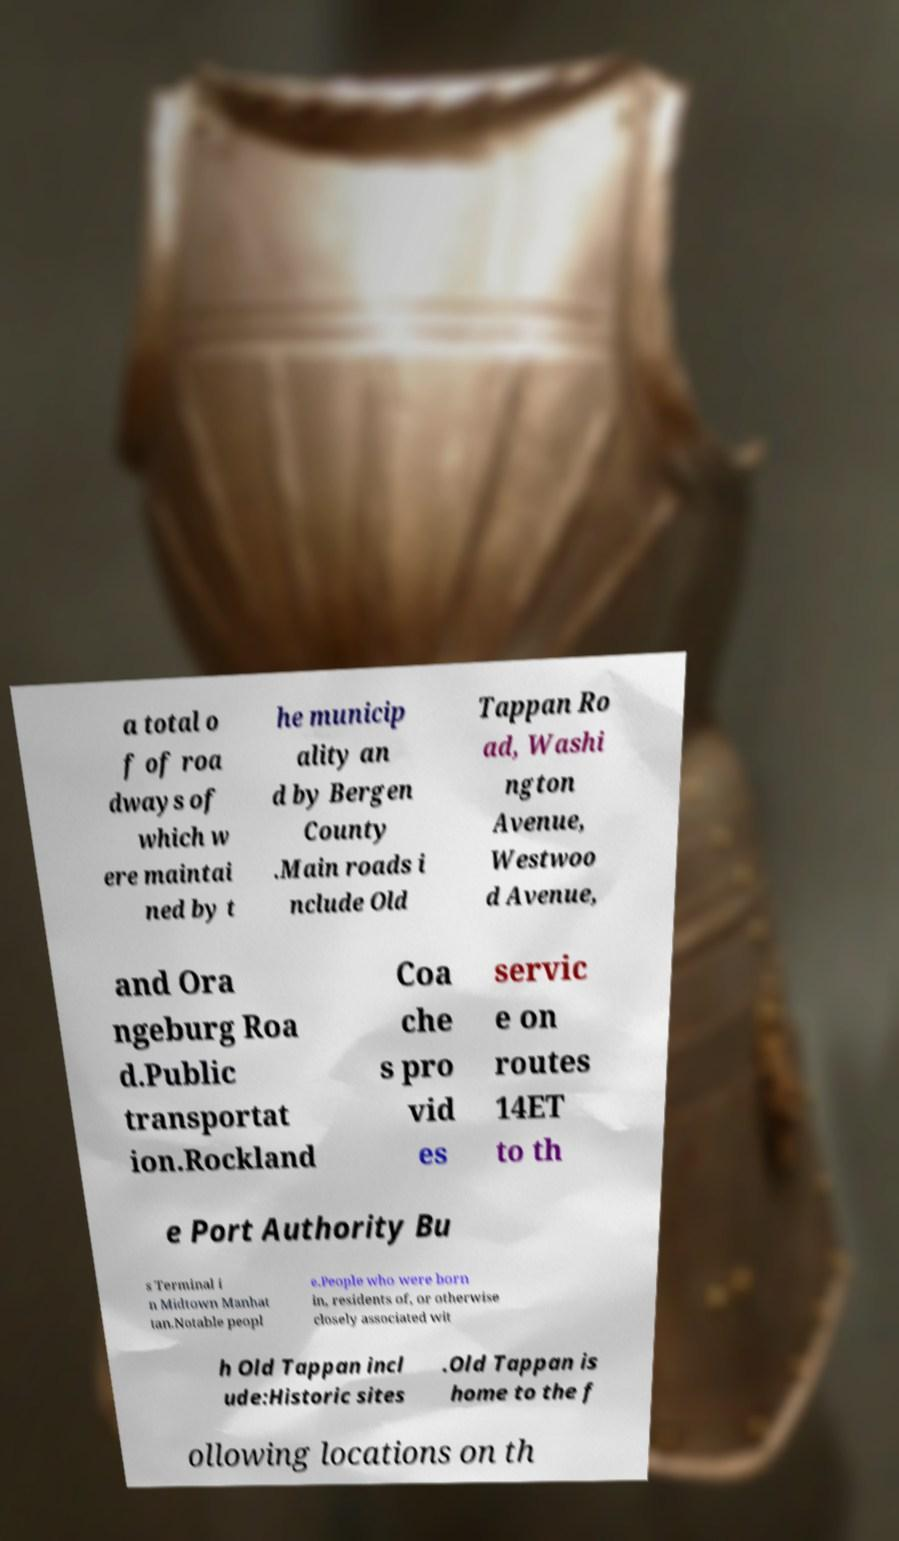Please identify and transcribe the text found in this image. a total o f of roa dways of which w ere maintai ned by t he municip ality an d by Bergen County .Main roads i nclude Old Tappan Ro ad, Washi ngton Avenue, Westwoo d Avenue, and Ora ngeburg Roa d.Public transportat ion.Rockland Coa che s pro vid es servic e on routes 14ET to th e Port Authority Bu s Terminal i n Midtown Manhat tan.Notable peopl e.People who were born in, residents of, or otherwise closely associated wit h Old Tappan incl ude:Historic sites .Old Tappan is home to the f ollowing locations on th 